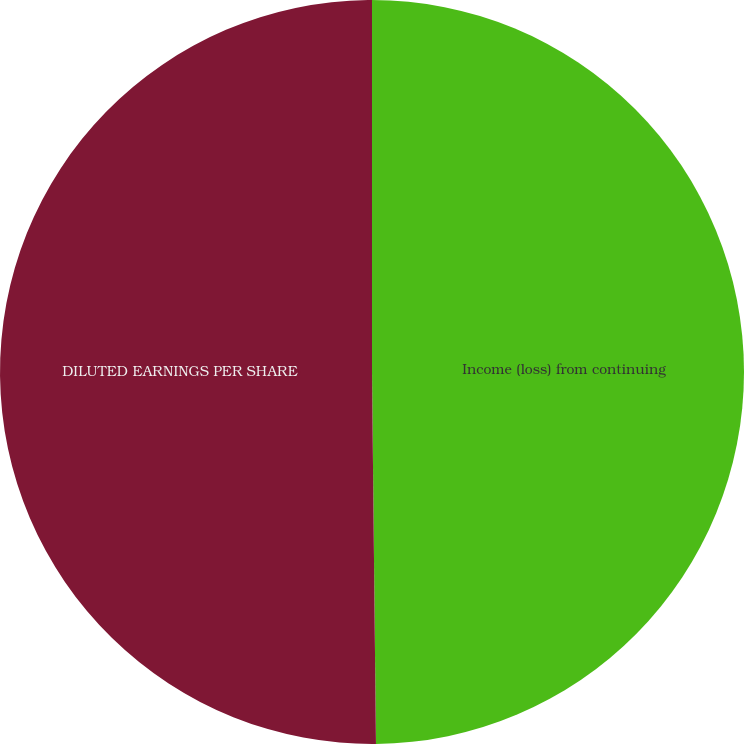<chart> <loc_0><loc_0><loc_500><loc_500><pie_chart><fcel>Income (loss) from continuing<fcel>DILUTED EARNINGS PER SHARE<nl><fcel>49.83%<fcel>50.17%<nl></chart> 